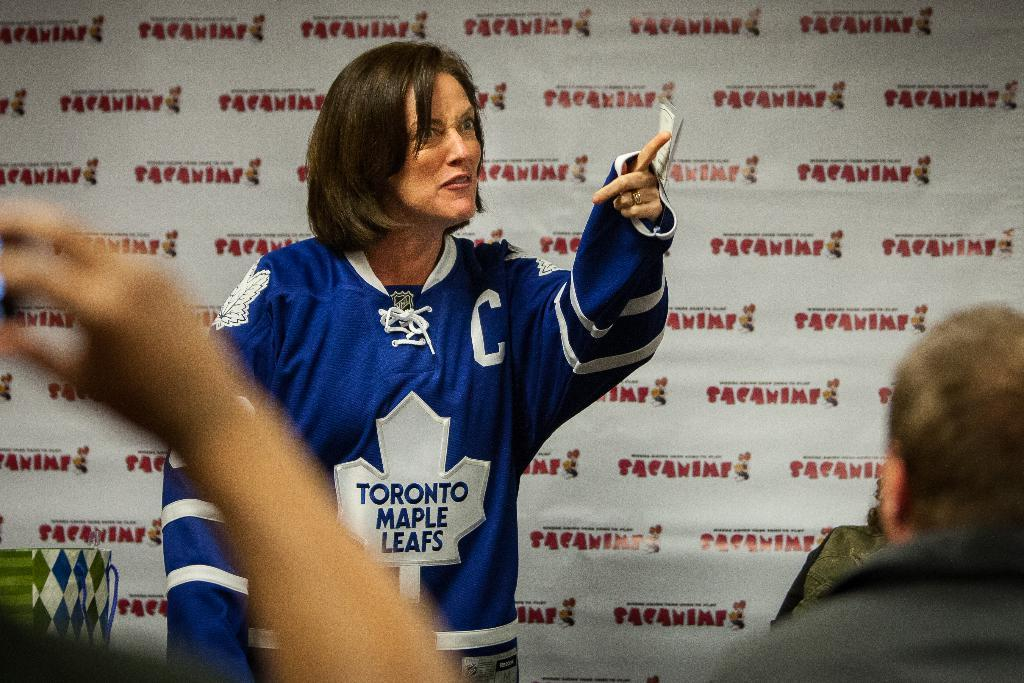<image>
Provide a brief description of the given image. Woman wearing a blue jersey which says Maple Leafs on it. 